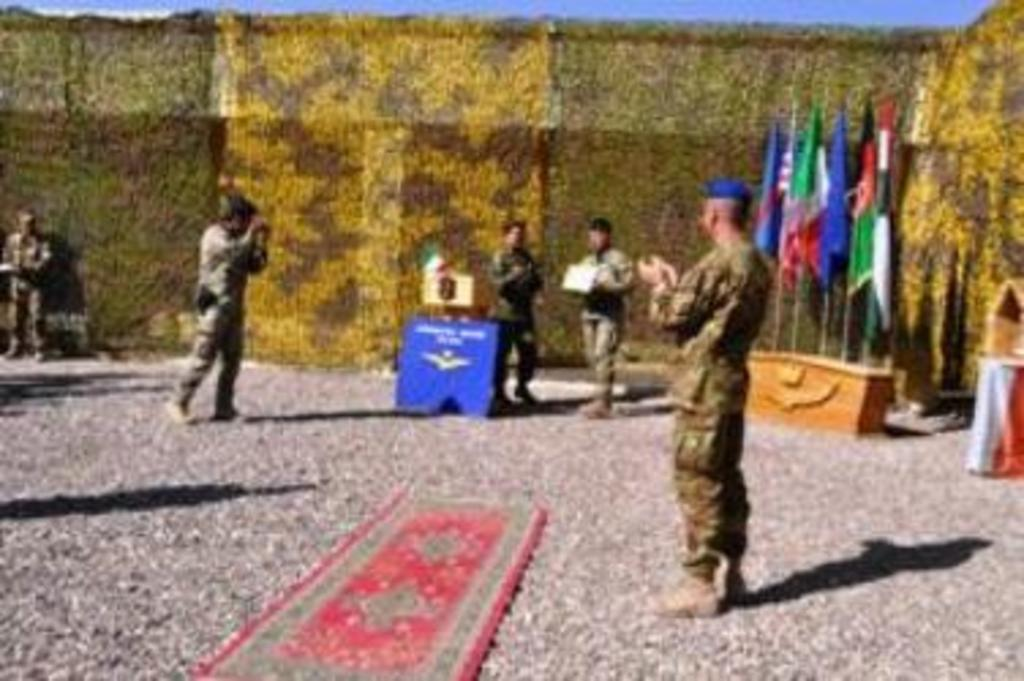What is on the floor in the image? There is a mat on the floor. What can be seen in the foreground of the image? A person is standing in the foreground of the image. What decorative elements are present in the image? There are flags visible in the image. How many people are in the image? There are people in the image. What is visible in the background of the image? It seems like there is a curtain in the background, and the sky is visible as well. Can you see any roses floating in the lake in the image? There is no lake or roses present in the image. How many apples are being held by the person in the image? There are no apples visible in the image. 